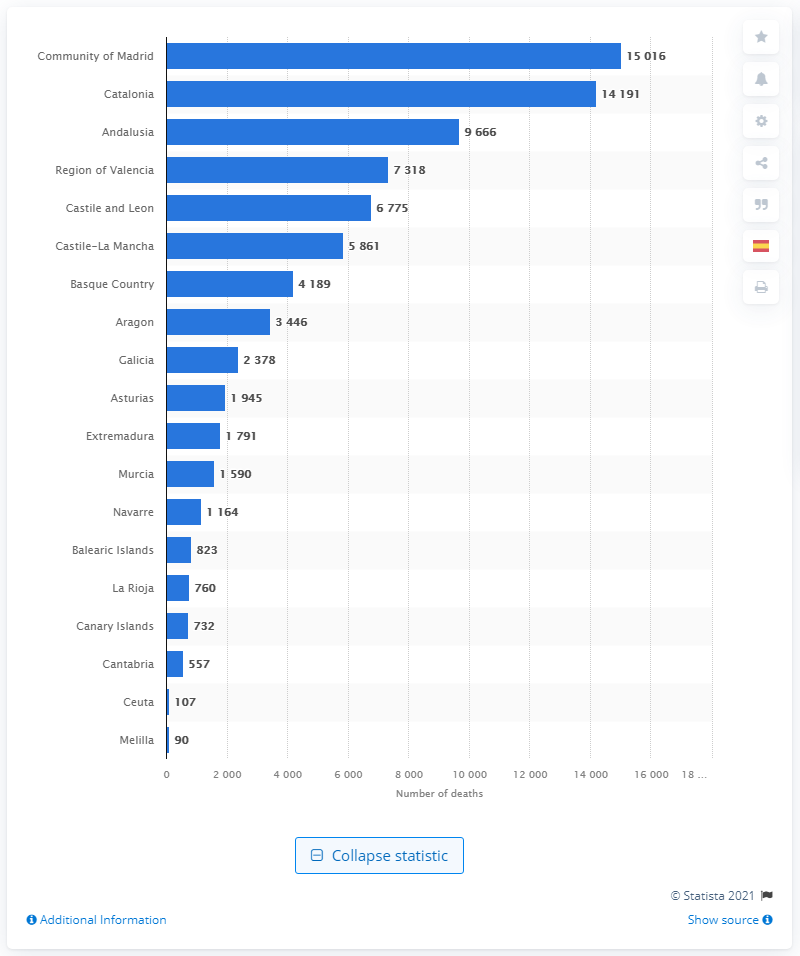Please provide a summary of the data trends shown in this chart. The chart illustrates a clear disparity in the number of deaths due to coronavirus among various regions. The Community of Madrid has the highest figures, indicating a significant impact there, while other regions like Catalonia and Andalusia also show high numbers. In contrast, the regions of Melilla and Ceuta have the lowest recorded deaths, which may correlate with population density, healthcare resources, or other regional factors. 